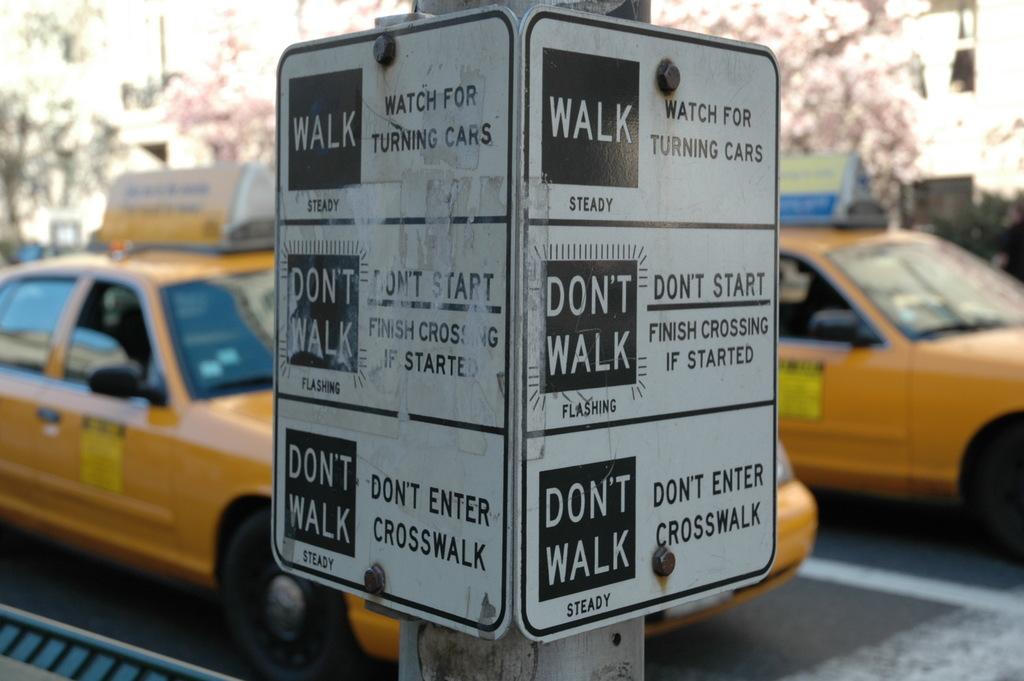What is the sign explaining?
Provide a succinct answer. Walk and don't walk. Watch for what?
Offer a terse response. Turning cars. 